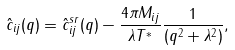Convert formula to latex. <formula><loc_0><loc_0><loc_500><loc_500>\hat { c } _ { i j } ( q ) = \hat { c } _ { i j } ^ { s r } ( q ) - \frac { 4 \pi M _ { i j } } { \lambda T ^ { * } } \frac { 1 } { ( q ^ { 2 } + \lambda ^ { 2 } ) } ,</formula> 